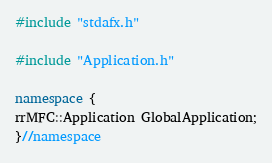<code> <loc_0><loc_0><loc_500><loc_500><_C++_>#include "stdafx.h"

#include "Application.h"

namespace {
rrMFC::Application GlobalApplication;
}//namespace
</code> 